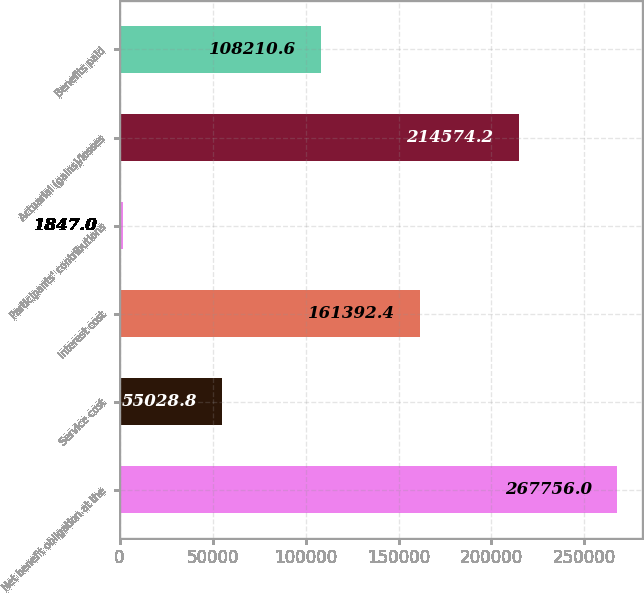Convert chart to OTSL. <chart><loc_0><loc_0><loc_500><loc_500><bar_chart><fcel>Net benefit obligation at the<fcel>Service cost<fcel>Interest cost<fcel>Participants' contributions<fcel>Actuarial (gains)/losses<fcel>Benefits paid<nl><fcel>267756<fcel>55028.8<fcel>161392<fcel>1847<fcel>214574<fcel>108211<nl></chart> 